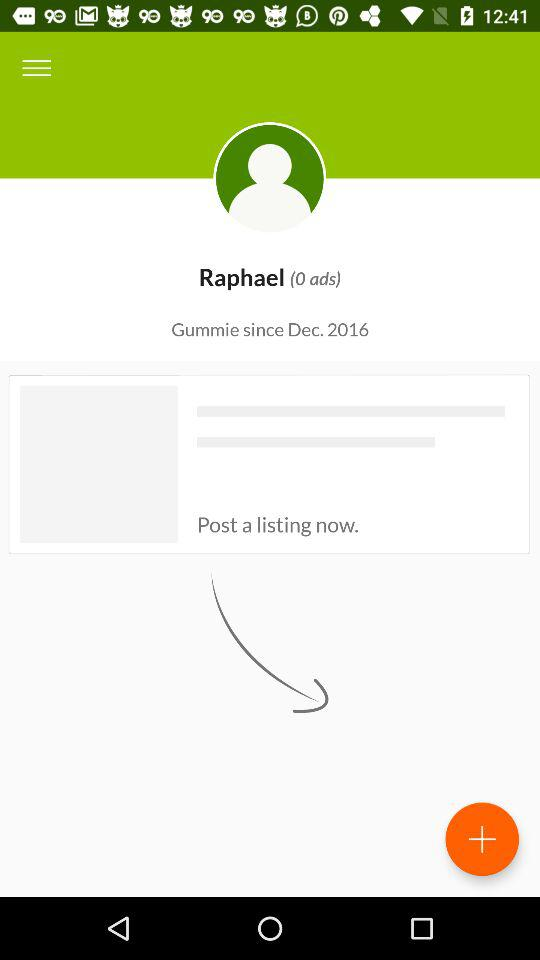How many ads are there? There are 0 ads. 